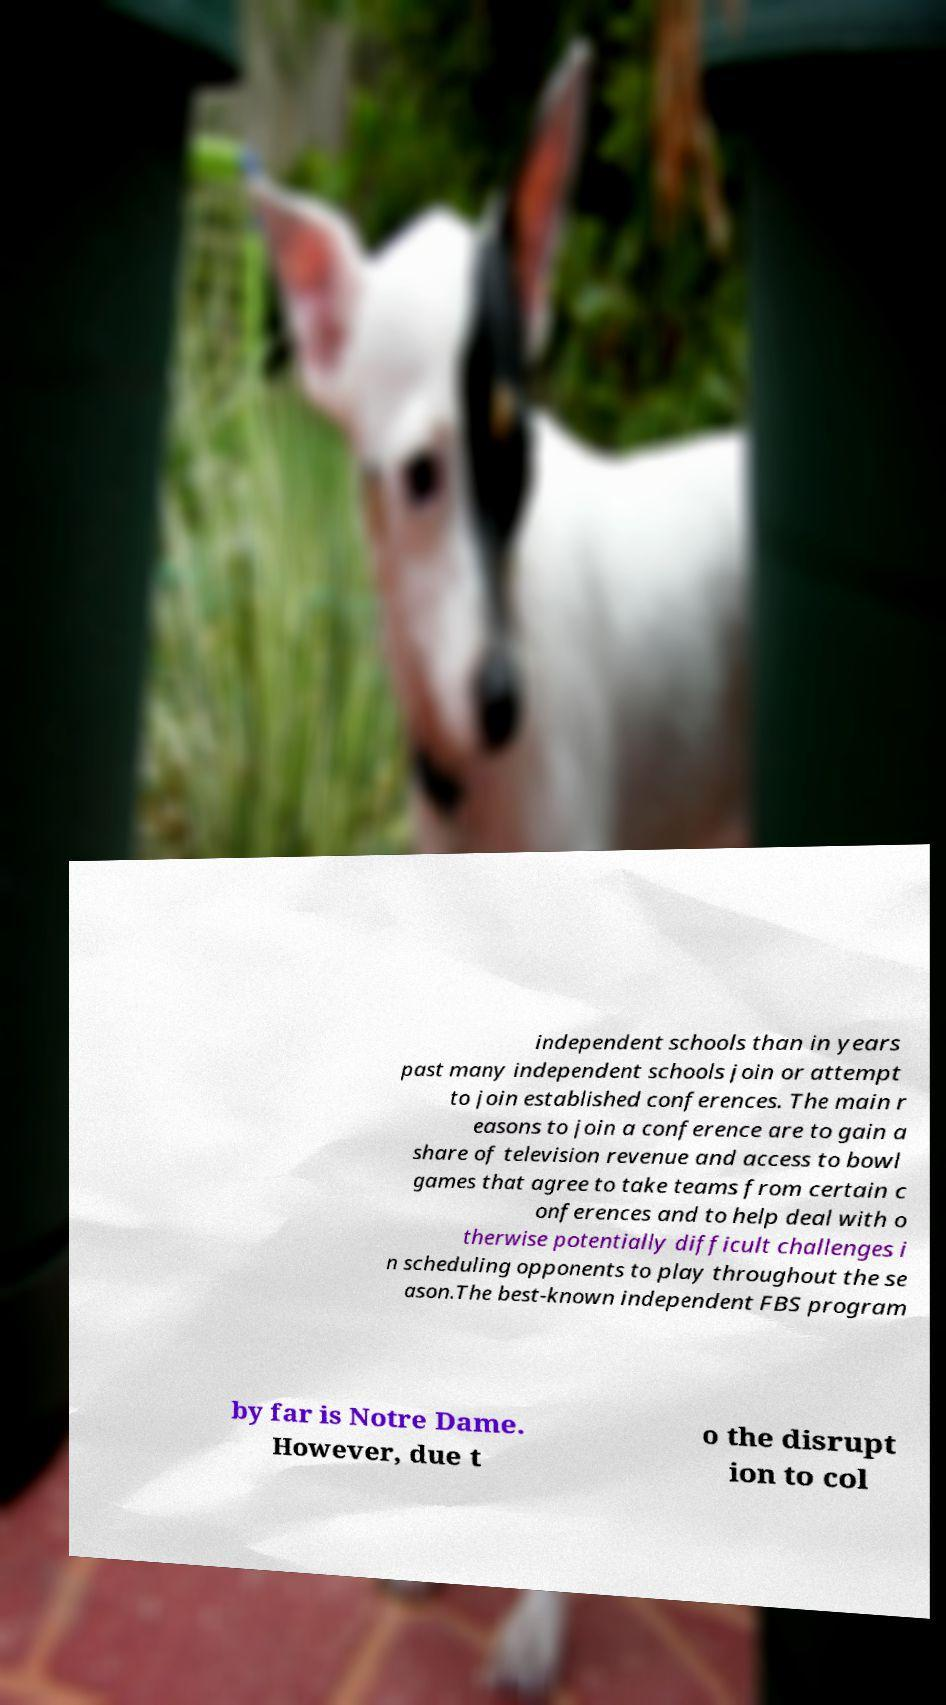What messages or text are displayed in this image? I need them in a readable, typed format. independent schools than in years past many independent schools join or attempt to join established conferences. The main r easons to join a conference are to gain a share of television revenue and access to bowl games that agree to take teams from certain c onferences and to help deal with o therwise potentially difficult challenges i n scheduling opponents to play throughout the se ason.The best-known independent FBS program by far is Notre Dame. However, due t o the disrupt ion to col 